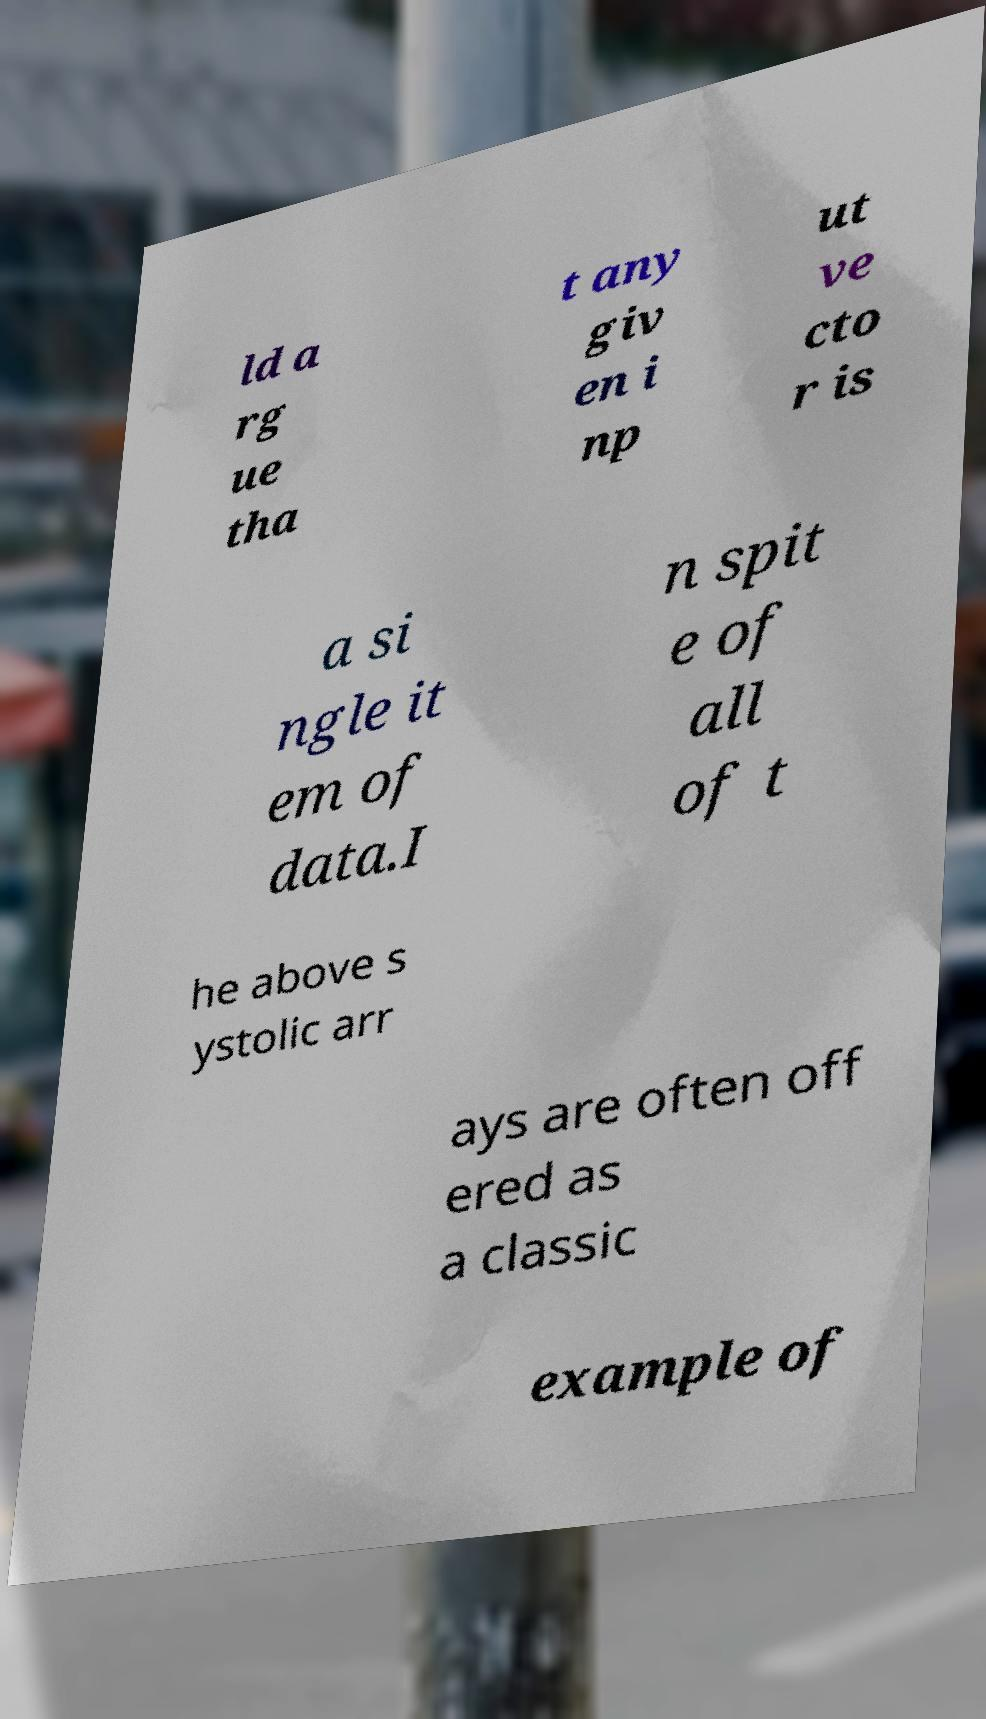Can you accurately transcribe the text from the provided image for me? ld a rg ue tha t any giv en i np ut ve cto r is a si ngle it em of data.I n spit e of all of t he above s ystolic arr ays are often off ered as a classic example of 